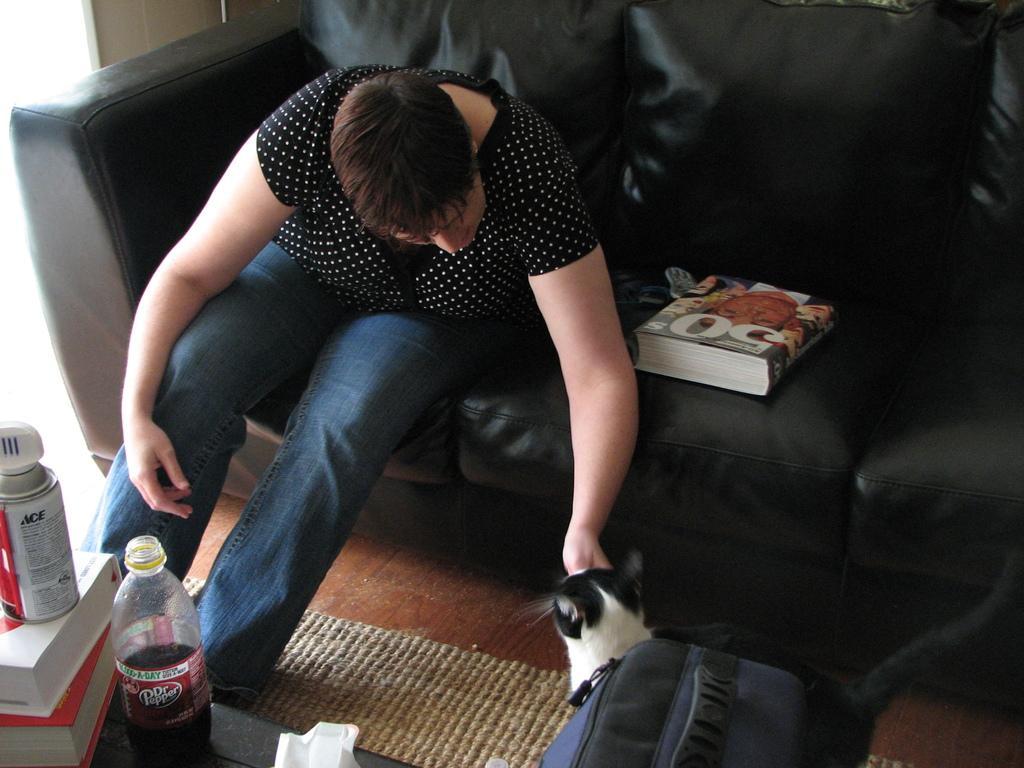In one or two sentences, can you explain what this image depicts? This is a picture taken in a house. On the left there is a table, on the table there are books, spray and a bottle. On the right there is a backpack and the cat. In the center there is a couch, on the couch women and a book. On the top left there is a window. 